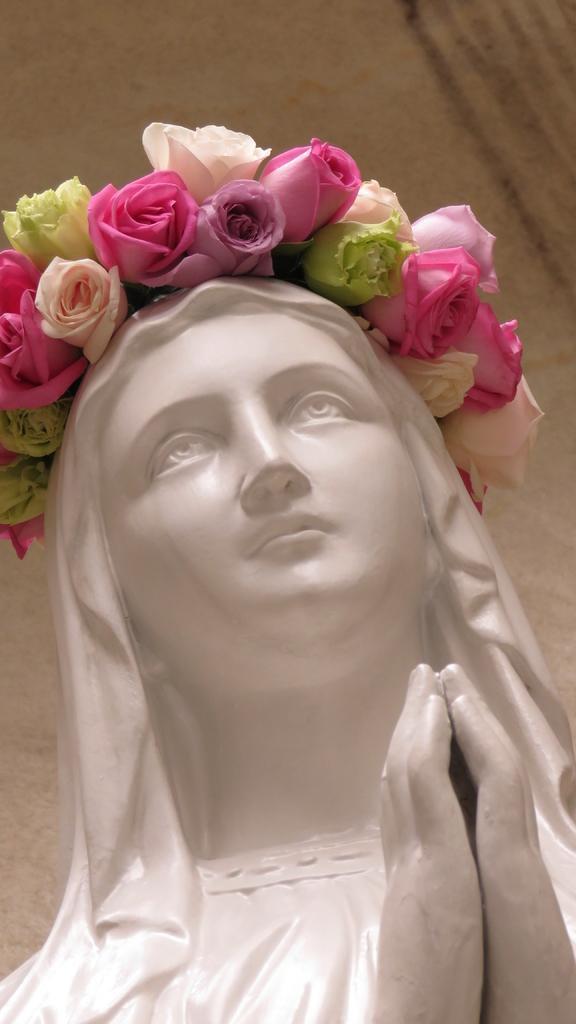Please provide a concise description of this image. There is a woman's statue in white color, wearing flower crown and joined both hands together. In the background, there is wall. 